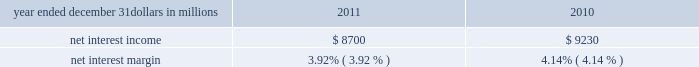Corporate & institutional banking corporate & institutional banking earned $ 1.9 billion in 2011 and $ 1.8 billion in 2010 .
The increase in earnings was primarily due to an improvement in the provision for credit losses , which was a benefit in 2011 , partially offset by a reduction in the value of commercial mortgage servicing rights and lower net interest income .
We continued to focus on adding new clients , increasing cross sales , and remaining committed to strong expense discipline .
Asset management group asset management group earned $ 141 million for 2011 compared with $ 137 million for 2010 .
Assets under administration were $ 210 billion at december 31 , 2011 and $ 212 billion at december 31 , 2010 .
Earnings for 2011 reflected a benefit from the provision for credit losses and growth in noninterest income , partially offset by higher noninterest expense and lower net interest income .
For 2011 , the business delivered strong sales production , grew high value clients and benefitted from significant referrals from other pnc lines of business .
Over time and with stabilized market conditions , the successful execution of these strategies and the accumulation of our strong sales performance are expected to create meaningful growth in assets under management and noninterest income .
Residential mortgage banking residential mortgage banking earned $ 87 million in 2011 compared with $ 269 million in 2010 .
The decline in earnings was driven by an increase in noninterest expense associated with increased costs for residential mortgage foreclosure- related expenses , primarily as a result of ongoing governmental matters , and lower net interest income , partially offset by an increase in loan originations and higher loans sales revenue .
Blackrock our blackrock business segment earned $ 361 million in 2011 and $ 351 million in 2010 .
The higher business segment earnings from blackrock for 2011 compared with 2010 were primarily due to an increase in revenue .
Non-strategic assets portfolio this business segment ( formerly distressed assets portfolio ) consists primarily of acquired non-strategic assets that fall outside of our core business strategy .
Non-strategic assets portfolio had earnings of $ 200 million in 2011 compared with a loss of $ 57 million in 2010 .
The increase was primarily attributable to a lower provision for credit losses partially offset by lower net interest income .
201cother 201d reported earnings of $ 376 million for 2011 compared with earnings of $ 386 million for 2010 .
The decrease in earnings primarily reflected the noncash charge related to the redemption of trust preferred securities in the fourth quarter of 2011 and the gain related to the sale of a portion of pnc 2019s blackrock shares in 2010 partially offset by lower integration costs in 2011 .
Consolidated income statement review our consolidated income statement is presented in item 8 of this report .
Net income for 2011 was $ 3.1 billion compared with $ 3.4 billion for 2010 .
Results for 2011 include the impact of $ 324 million of residential mortgage foreclosure-related expenses primarily as a result of ongoing governmental matters , a $ 198 million noncash charge related to redemption of trust preferred securities and $ 42 million for integration costs .
Results for 2010 included the $ 328 million after-tax gain on our sale of gis , $ 387 million for integration costs , and $ 71 million of residential mortgage foreclosure-related expenses .
For 2010 , net income attributable to common shareholders was also impacted by a noncash reduction of $ 250 million in connection with the redemption of tarp preferred stock .
Pnc 2019s results for 2011 were driven by good performance in a challenging environment of low interest rates , slow economic growth and new regulations .
Net interest income and net interest margin year ended december 31 dollars in millions 2011 2010 .
Changes in net interest income and margin result from the interaction of the volume and composition of interest-earning assets and related yields , interest-bearing liabilities and related rates paid , and noninterest-bearing sources of funding .
See the statistical information ( unaudited ) 2013 analysis of year-to-year changes in net interest income and average consolidated balance sheet and net interest analysis in item 8 and the discussion of purchase accounting accretion in the consolidated balance sheet review in item 7 of this report for additional information .
The decreases in net interest income and net interest margin for 2011 compared with 2010 were primarily attributable to a decrease in purchase accounting accretion on purchased impaired loans primarily due to lower excess cash recoveries .
A decline in average loan balances and the low interest rate environment , partially offset by lower funding costs , also contributed to the decrease .
The pnc financial services group , inc .
2013 form 10-k 35 .
What was the total black rock business segment figures for 2010 and 2011? 
Computations: (361 + 351)
Answer: 712.0. Corporate & institutional banking corporate & institutional banking earned $ 1.9 billion in 2011 and $ 1.8 billion in 2010 .
The increase in earnings was primarily due to an improvement in the provision for credit losses , which was a benefit in 2011 , partially offset by a reduction in the value of commercial mortgage servicing rights and lower net interest income .
We continued to focus on adding new clients , increasing cross sales , and remaining committed to strong expense discipline .
Asset management group asset management group earned $ 141 million for 2011 compared with $ 137 million for 2010 .
Assets under administration were $ 210 billion at december 31 , 2011 and $ 212 billion at december 31 , 2010 .
Earnings for 2011 reflected a benefit from the provision for credit losses and growth in noninterest income , partially offset by higher noninterest expense and lower net interest income .
For 2011 , the business delivered strong sales production , grew high value clients and benefitted from significant referrals from other pnc lines of business .
Over time and with stabilized market conditions , the successful execution of these strategies and the accumulation of our strong sales performance are expected to create meaningful growth in assets under management and noninterest income .
Residential mortgage banking residential mortgage banking earned $ 87 million in 2011 compared with $ 269 million in 2010 .
The decline in earnings was driven by an increase in noninterest expense associated with increased costs for residential mortgage foreclosure- related expenses , primarily as a result of ongoing governmental matters , and lower net interest income , partially offset by an increase in loan originations and higher loans sales revenue .
Blackrock our blackrock business segment earned $ 361 million in 2011 and $ 351 million in 2010 .
The higher business segment earnings from blackrock for 2011 compared with 2010 were primarily due to an increase in revenue .
Non-strategic assets portfolio this business segment ( formerly distressed assets portfolio ) consists primarily of acquired non-strategic assets that fall outside of our core business strategy .
Non-strategic assets portfolio had earnings of $ 200 million in 2011 compared with a loss of $ 57 million in 2010 .
The increase was primarily attributable to a lower provision for credit losses partially offset by lower net interest income .
201cother 201d reported earnings of $ 376 million for 2011 compared with earnings of $ 386 million for 2010 .
The decrease in earnings primarily reflected the noncash charge related to the redemption of trust preferred securities in the fourth quarter of 2011 and the gain related to the sale of a portion of pnc 2019s blackrock shares in 2010 partially offset by lower integration costs in 2011 .
Consolidated income statement review our consolidated income statement is presented in item 8 of this report .
Net income for 2011 was $ 3.1 billion compared with $ 3.4 billion for 2010 .
Results for 2011 include the impact of $ 324 million of residential mortgage foreclosure-related expenses primarily as a result of ongoing governmental matters , a $ 198 million noncash charge related to redemption of trust preferred securities and $ 42 million for integration costs .
Results for 2010 included the $ 328 million after-tax gain on our sale of gis , $ 387 million for integration costs , and $ 71 million of residential mortgage foreclosure-related expenses .
For 2010 , net income attributable to common shareholders was also impacted by a noncash reduction of $ 250 million in connection with the redemption of tarp preferred stock .
Pnc 2019s results for 2011 were driven by good performance in a challenging environment of low interest rates , slow economic growth and new regulations .
Net interest income and net interest margin year ended december 31 dollars in millions 2011 2010 .
Changes in net interest income and margin result from the interaction of the volume and composition of interest-earning assets and related yields , interest-bearing liabilities and related rates paid , and noninterest-bearing sources of funding .
See the statistical information ( unaudited ) 2013 analysis of year-to-year changes in net interest income and average consolidated balance sheet and net interest analysis in item 8 and the discussion of purchase accounting accretion in the consolidated balance sheet review in item 7 of this report for additional information .
The decreases in net interest income and net interest margin for 2011 compared with 2010 were primarily attributable to a decrease in purchase accounting accretion on purchased impaired loans primarily due to lower excess cash recoveries .
A decline in average loan balances and the low interest rate environment , partially offset by lower funding costs , also contributed to the decrease .
The pnc financial services group , inc .
2013 form 10-k 35 .
How much more was the residential mortgage foreclosures in 2011 than in 2010? 
Computations: (324 - 71)
Answer: 253.0. 